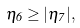<formula> <loc_0><loc_0><loc_500><loc_500>\eta _ { 6 } \geq | \eta _ { 7 } | ,</formula> 